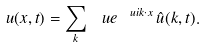Convert formula to latex. <formula><loc_0><loc_0><loc_500><loc_500>u ( x , t ) = \sum _ { k } \ u e ^ { \ u i k \cdot x } \, \hat { u } ( k , t ) .</formula> 